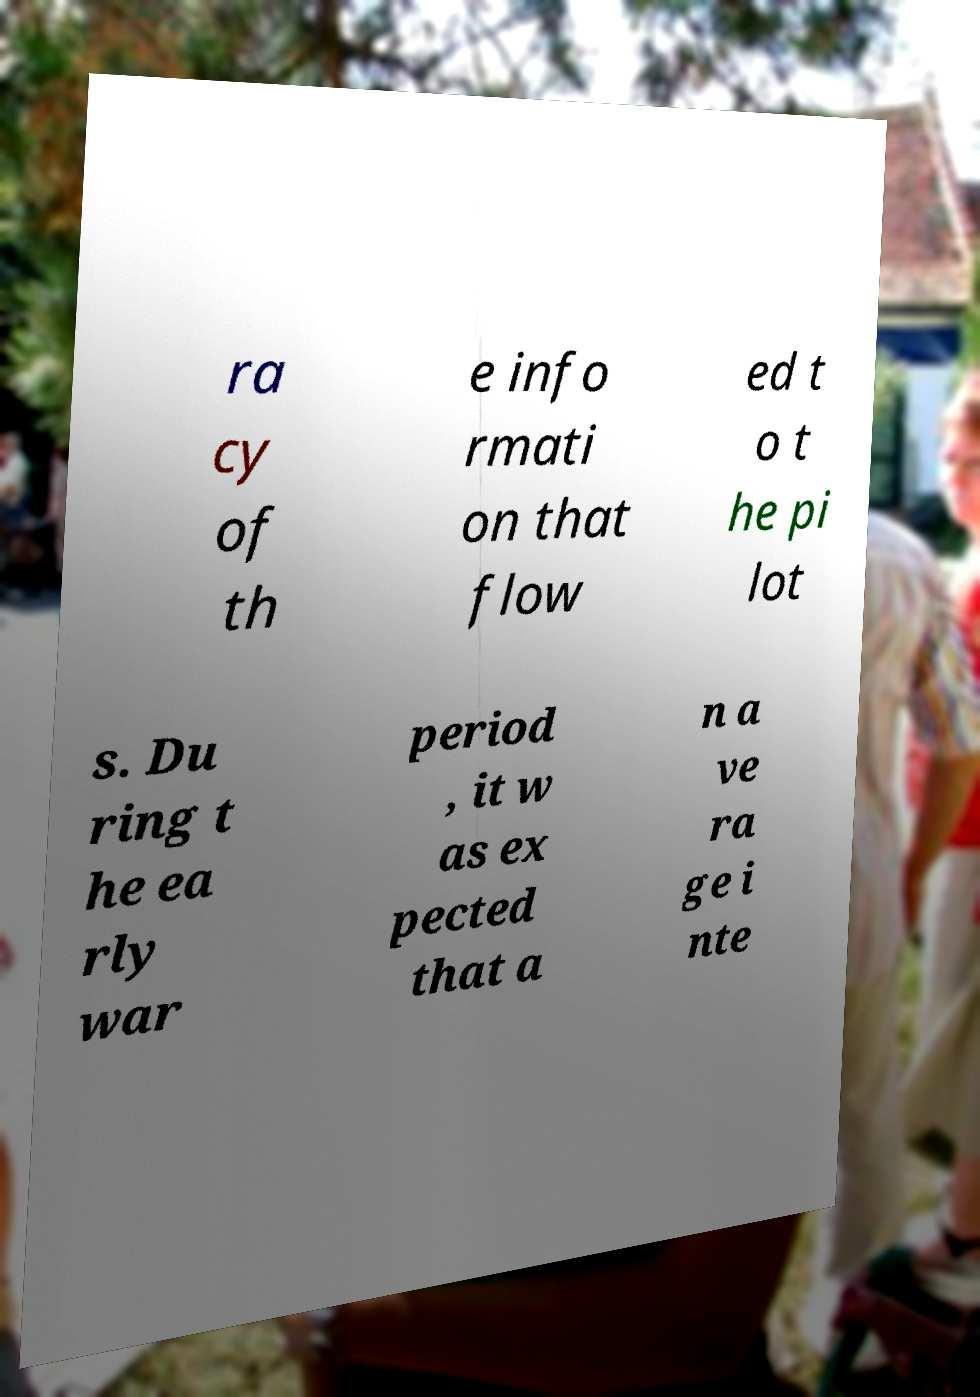There's text embedded in this image that I need extracted. Can you transcribe it verbatim? ra cy of th e info rmati on that flow ed t o t he pi lot s. Du ring t he ea rly war period , it w as ex pected that a n a ve ra ge i nte 